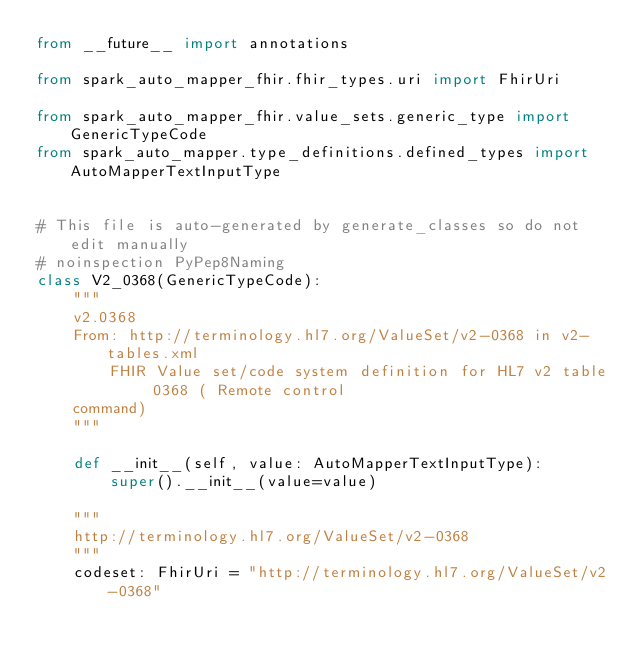<code> <loc_0><loc_0><loc_500><loc_500><_Python_>from __future__ import annotations

from spark_auto_mapper_fhir.fhir_types.uri import FhirUri

from spark_auto_mapper_fhir.value_sets.generic_type import GenericTypeCode
from spark_auto_mapper.type_definitions.defined_types import AutoMapperTextInputType


# This file is auto-generated by generate_classes so do not edit manually
# noinspection PyPep8Naming
class V2_0368(GenericTypeCode):
    """
    v2.0368
    From: http://terminology.hl7.org/ValueSet/v2-0368 in v2-tables.xml
        FHIR Value set/code system definition for HL7 v2 table 0368 ( Remote control
    command)
    """

    def __init__(self, value: AutoMapperTextInputType):
        super().__init__(value=value)

    """
    http://terminology.hl7.org/ValueSet/v2-0368
    """
    codeset: FhirUri = "http://terminology.hl7.org/ValueSet/v2-0368"
</code> 